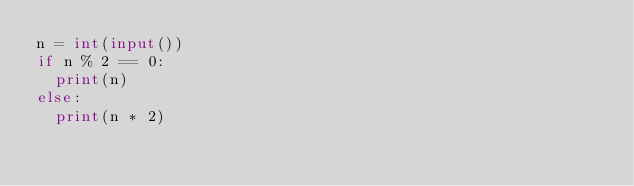<code> <loc_0><loc_0><loc_500><loc_500><_Python_>n = int(input())
if n % 2 == 0:
  print(n)
else:
  print(n * 2)</code> 